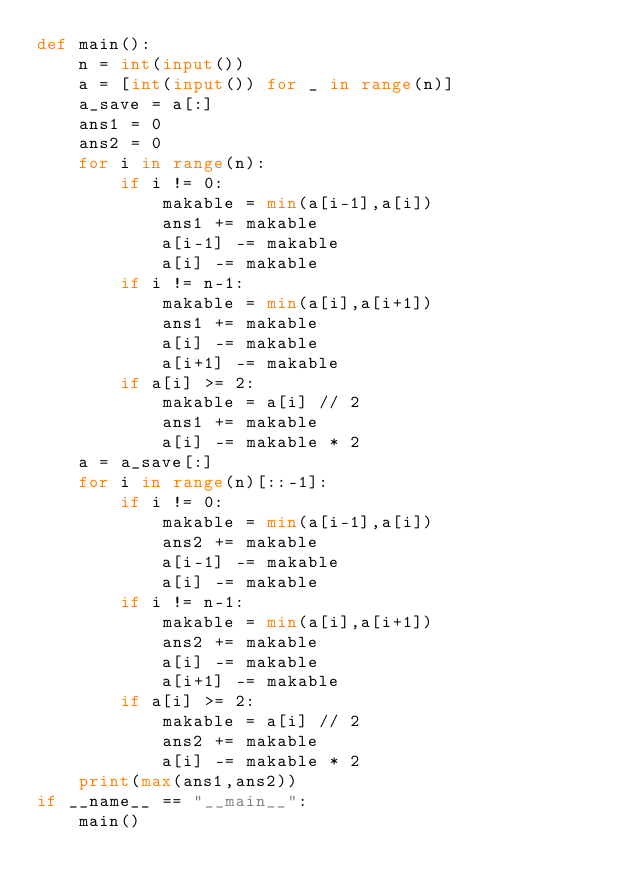<code> <loc_0><loc_0><loc_500><loc_500><_Python_>def main():
    n = int(input())
    a = [int(input()) for _ in range(n)]
    a_save = a[:]
    ans1 = 0
    ans2 = 0
    for i in range(n):
        if i != 0:
            makable = min(a[i-1],a[i])
            ans1 += makable
            a[i-1] -= makable
            a[i] -= makable
        if i != n-1:
            makable = min(a[i],a[i+1])
            ans1 += makable
            a[i] -= makable
            a[i+1] -= makable
        if a[i] >= 2:
            makable = a[i] // 2
            ans1 += makable
            a[i] -= makable * 2
    a = a_save[:]
    for i in range(n)[::-1]:
        if i != 0:
            makable = min(a[i-1],a[i])
            ans2 += makable
            a[i-1] -= makable
            a[i] -= makable
        if i != n-1:
            makable = min(a[i],a[i+1])
            ans2 += makable
            a[i] -= makable
            a[i+1] -= makable
        if a[i] >= 2:
            makable = a[i] // 2
            ans2 += makable
            a[i] -= makable * 2
    print(max(ans1,ans2))
if __name__ == "__main__":
    main()</code> 